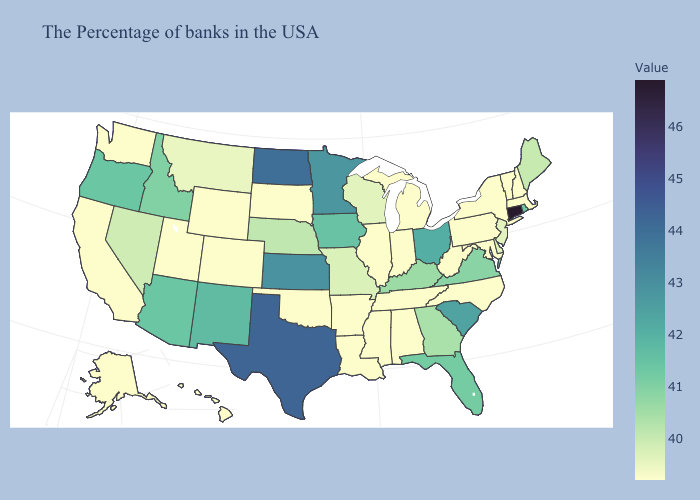Does Pennsylvania have the highest value in the Northeast?
Keep it brief. No. Among the states that border Michigan , which have the highest value?
Keep it brief. Ohio. Among the states that border Utah , which have the highest value?
Answer briefly. New Mexico. Does Iowa have the lowest value in the USA?
Short answer required. No. Which states hav the highest value in the MidWest?
Quick response, please. North Dakota. Which states have the highest value in the USA?
Be succinct. Connecticut. 